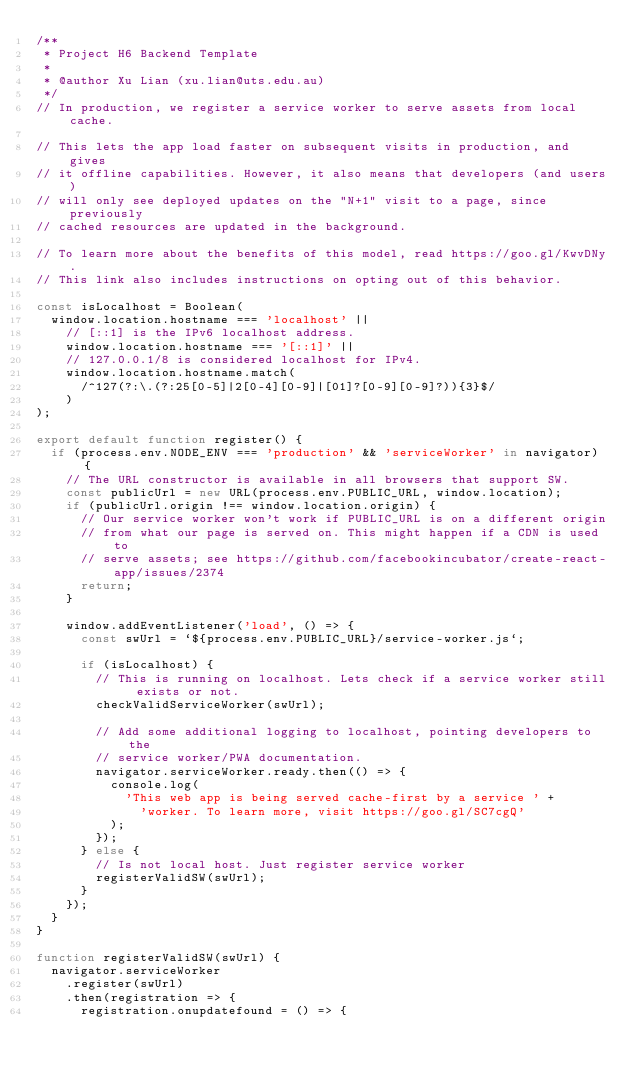<code> <loc_0><loc_0><loc_500><loc_500><_JavaScript_>/**
 * Project H6 Backend Template
 *
 * @author Xu Lian (xu.lian@uts.edu.au)
 */
// In production, we register a service worker to serve assets from local cache.

// This lets the app load faster on subsequent visits in production, and gives
// it offline capabilities. However, it also means that developers (and users)
// will only see deployed updates on the "N+1" visit to a page, since previously
// cached resources are updated in the background.

// To learn more about the benefits of this model, read https://goo.gl/KwvDNy.
// This link also includes instructions on opting out of this behavior.

const isLocalhost = Boolean(
  window.location.hostname === 'localhost' ||
    // [::1] is the IPv6 localhost address.
    window.location.hostname === '[::1]' ||
    // 127.0.0.1/8 is considered localhost for IPv4.
    window.location.hostname.match(
      /^127(?:\.(?:25[0-5]|2[0-4][0-9]|[01]?[0-9][0-9]?)){3}$/
    )
);

export default function register() {
  if (process.env.NODE_ENV === 'production' && 'serviceWorker' in navigator) {
    // The URL constructor is available in all browsers that support SW.
    const publicUrl = new URL(process.env.PUBLIC_URL, window.location);
    if (publicUrl.origin !== window.location.origin) {
      // Our service worker won't work if PUBLIC_URL is on a different origin
      // from what our page is served on. This might happen if a CDN is used to
      // serve assets; see https://github.com/facebookincubator/create-react-app/issues/2374
      return;
    }

    window.addEventListener('load', () => {
      const swUrl = `${process.env.PUBLIC_URL}/service-worker.js`;

      if (isLocalhost) {
        // This is running on localhost. Lets check if a service worker still exists or not.
        checkValidServiceWorker(swUrl);

        // Add some additional logging to localhost, pointing developers to the
        // service worker/PWA documentation.
        navigator.serviceWorker.ready.then(() => {
          console.log(
            'This web app is being served cache-first by a service ' +
              'worker. To learn more, visit https://goo.gl/SC7cgQ'
          );
        });
      } else {
        // Is not local host. Just register service worker
        registerValidSW(swUrl);
      }
    });
  }
}

function registerValidSW(swUrl) {
  navigator.serviceWorker
    .register(swUrl)
    .then(registration => {
      registration.onupdatefound = () => {</code> 